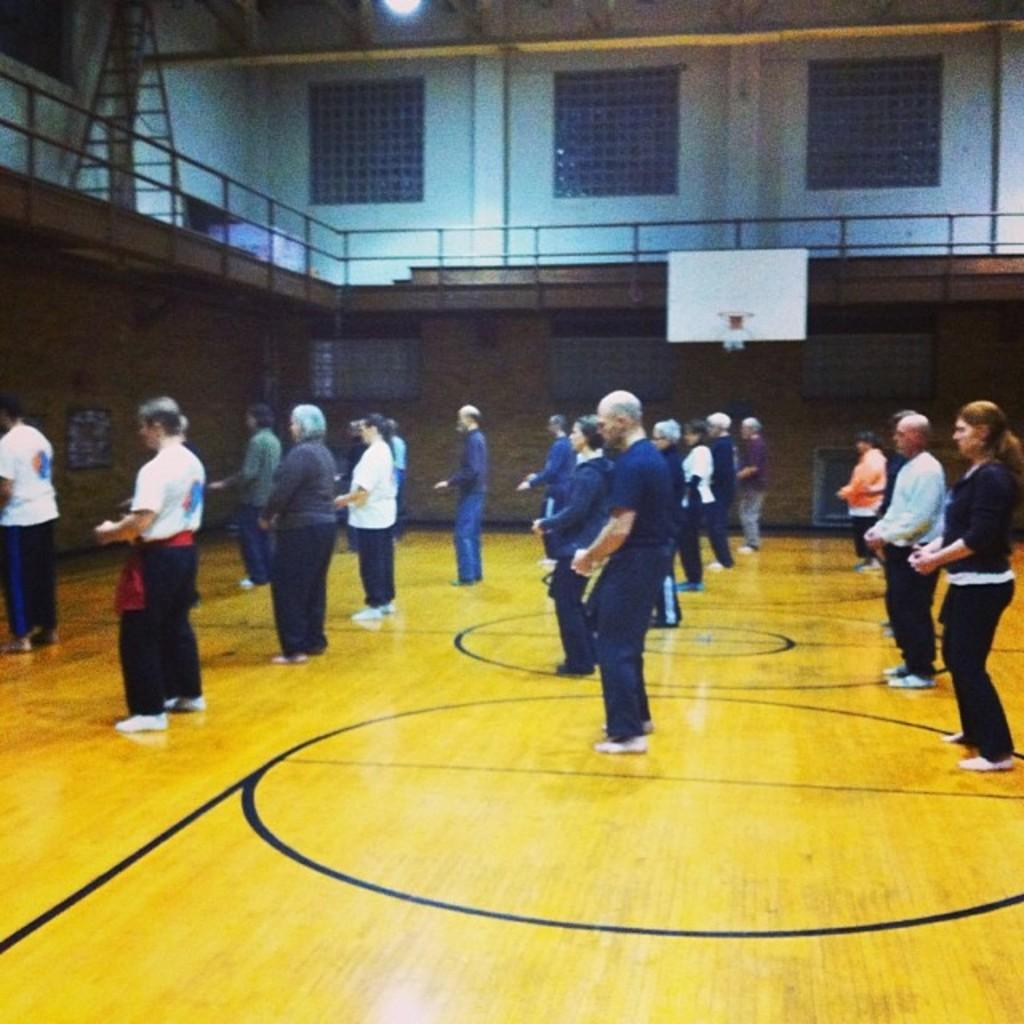What are the people in the image doing? The people in the image are standing. Where are the people standing in the image? The people are standing on the floor. What can be seen in the background of the image? In the background of the image, there is a railing, a wall, a board, windows, and a light. What type of punishment is being administered to the moon in the image? There is no moon present in the image, and therefore no punishment can be observed. What is the plate used for in the image? There is no plate present in the image. 